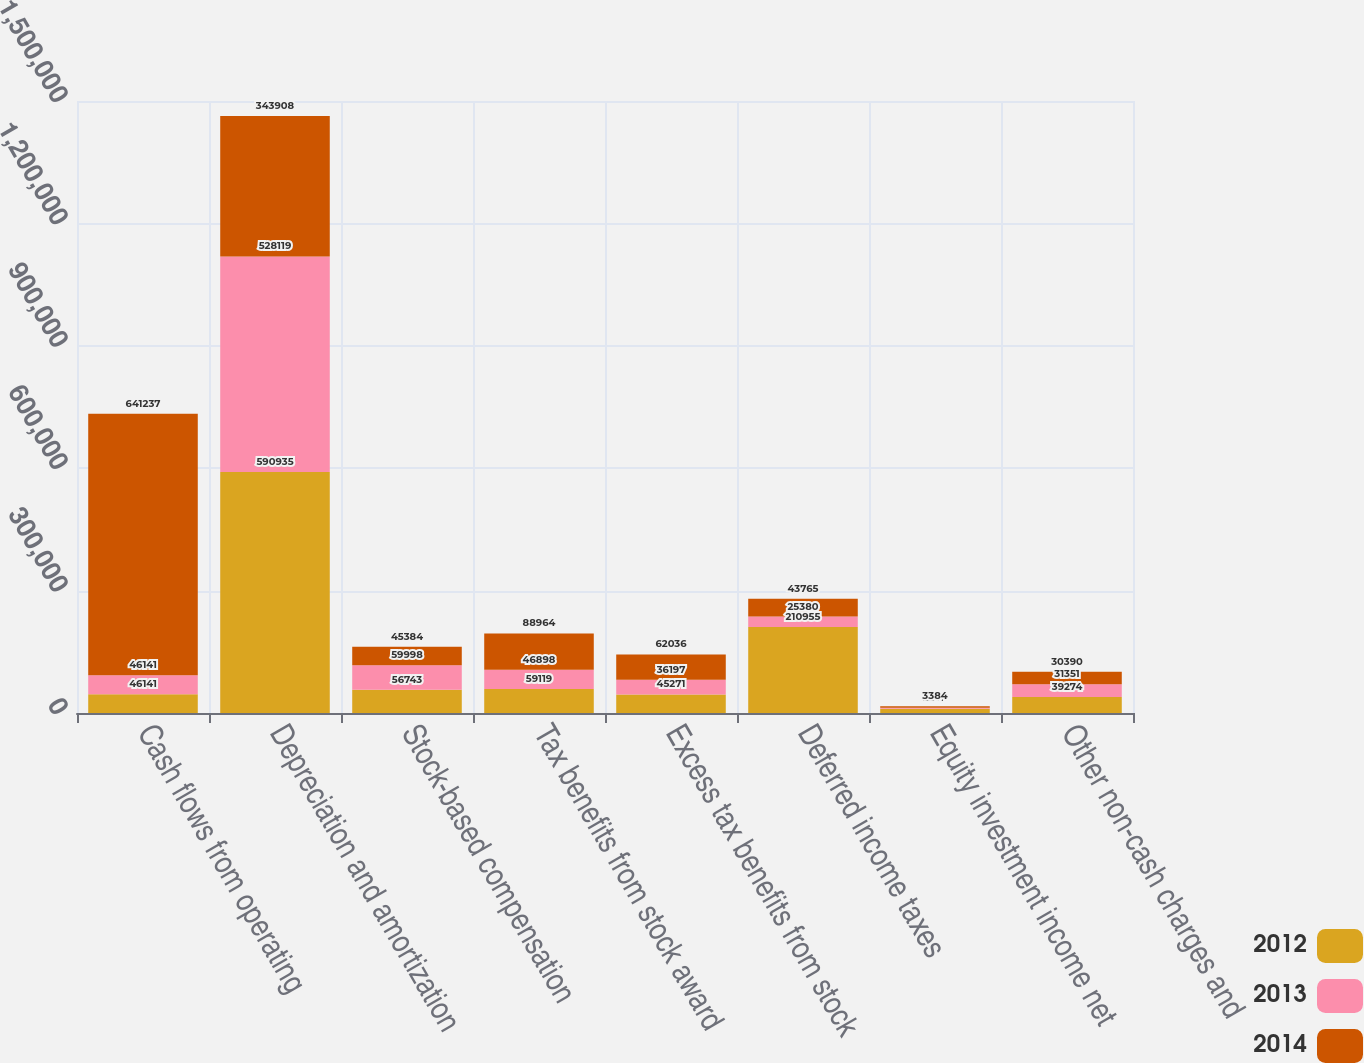<chart> <loc_0><loc_0><loc_500><loc_500><stacked_bar_chart><ecel><fcel>Cash flows from operating<fcel>Depreciation and amortization<fcel>Stock-based compensation<fcel>Tax benefits from stock award<fcel>Excess tax benefits from stock<fcel>Deferred income taxes<fcel>Equity investment income net<fcel>Other non-cash charges and<nl><fcel>2012<fcel>46141<fcel>590935<fcel>56743<fcel>59119<fcel>45271<fcel>210955<fcel>10125<fcel>39274<nl><fcel>2013<fcel>46141<fcel>528119<fcel>59998<fcel>46898<fcel>36197<fcel>25380<fcel>2872<fcel>31351<nl><fcel>2014<fcel>641237<fcel>343908<fcel>45384<fcel>88964<fcel>62036<fcel>43765<fcel>3384<fcel>30390<nl></chart> 